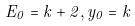<formula> <loc_0><loc_0><loc_500><loc_500>E _ { 0 } = k + 2 , y _ { 0 } = k</formula> 